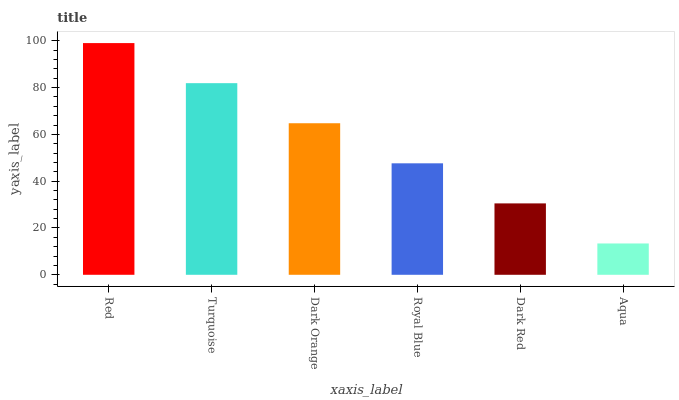Is Aqua the minimum?
Answer yes or no. Yes. Is Red the maximum?
Answer yes or no. Yes. Is Turquoise the minimum?
Answer yes or no. No. Is Turquoise the maximum?
Answer yes or no. No. Is Red greater than Turquoise?
Answer yes or no. Yes. Is Turquoise less than Red?
Answer yes or no. Yes. Is Turquoise greater than Red?
Answer yes or no. No. Is Red less than Turquoise?
Answer yes or no. No. Is Dark Orange the high median?
Answer yes or no. Yes. Is Royal Blue the low median?
Answer yes or no. Yes. Is Dark Red the high median?
Answer yes or no. No. Is Dark Red the low median?
Answer yes or no. No. 